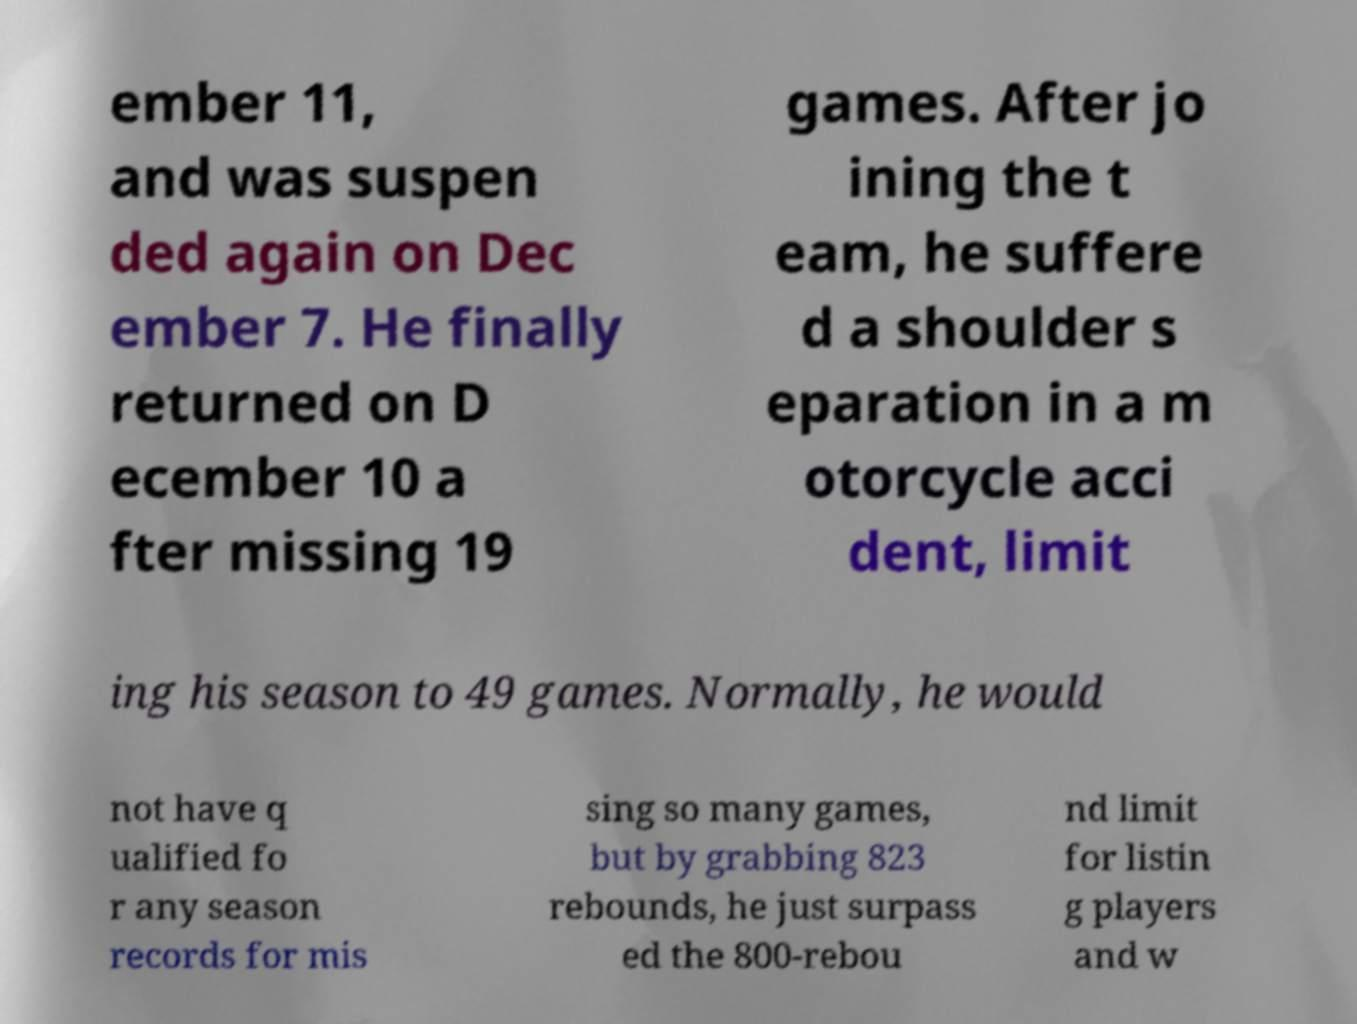Can you read and provide the text displayed in the image?This photo seems to have some interesting text. Can you extract and type it out for me? ember 11, and was suspen ded again on Dec ember 7. He finally returned on D ecember 10 a fter missing 19 games. After jo ining the t eam, he suffere d a shoulder s eparation in a m otorcycle acci dent, limit ing his season to 49 games. Normally, he would not have q ualified fo r any season records for mis sing so many games, but by grabbing 823 rebounds, he just surpass ed the 800-rebou nd limit for listin g players and w 